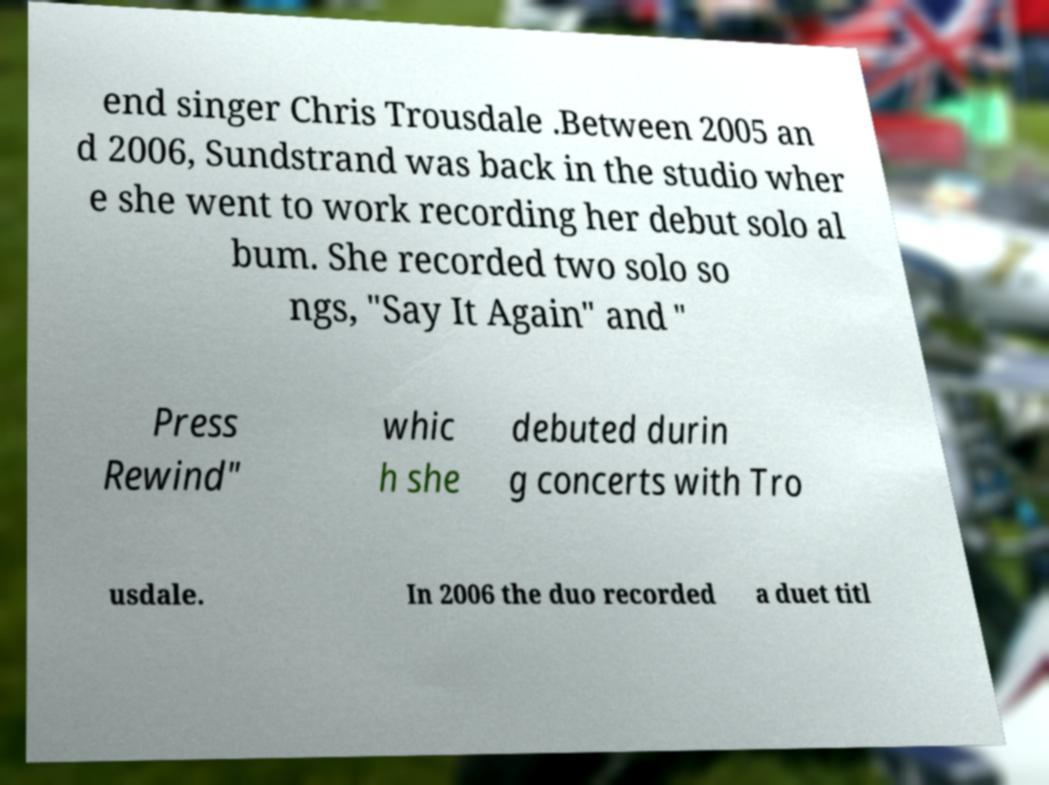Please read and relay the text visible in this image. What does it say? end singer Chris Trousdale .Between 2005 an d 2006, Sundstrand was back in the studio wher e she went to work recording her debut solo al bum. She recorded two solo so ngs, "Say It Again" and " Press Rewind" whic h she debuted durin g concerts with Tro usdale. In 2006 the duo recorded a duet titl 